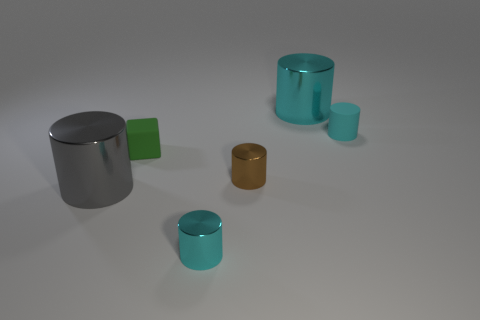Subtract all purple cubes. How many cyan cylinders are left? 3 Subtract all brown cylinders. How many cylinders are left? 4 Subtract all large gray cylinders. How many cylinders are left? 4 Subtract all purple cylinders. Subtract all brown cubes. How many cylinders are left? 5 Add 4 cubes. How many objects exist? 10 Subtract all cylinders. How many objects are left? 1 Add 4 small red matte things. How many small red matte things exist? 4 Subtract 0 blue cubes. How many objects are left? 6 Subtract all gray metal cylinders. Subtract all green rubber objects. How many objects are left? 4 Add 6 metal cylinders. How many metal cylinders are left? 10 